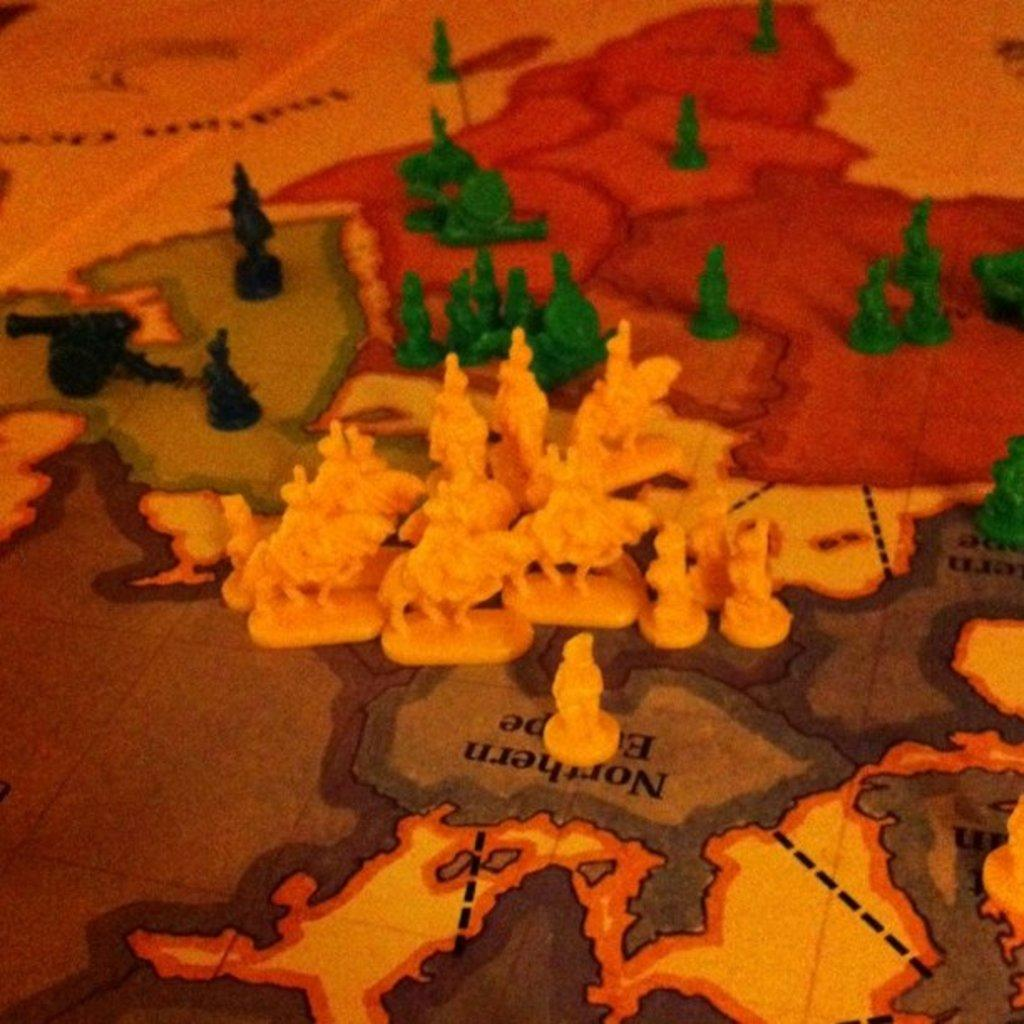What objects are present in the image? There are coins in the image. Can you describe the appearance of the coins? The coins have different colors. Where are the coins placed in the image? The coins are placed on a map chart. How many kittens are sitting on the coal pile in the image? There are no kittens or coal pile present in the image. 